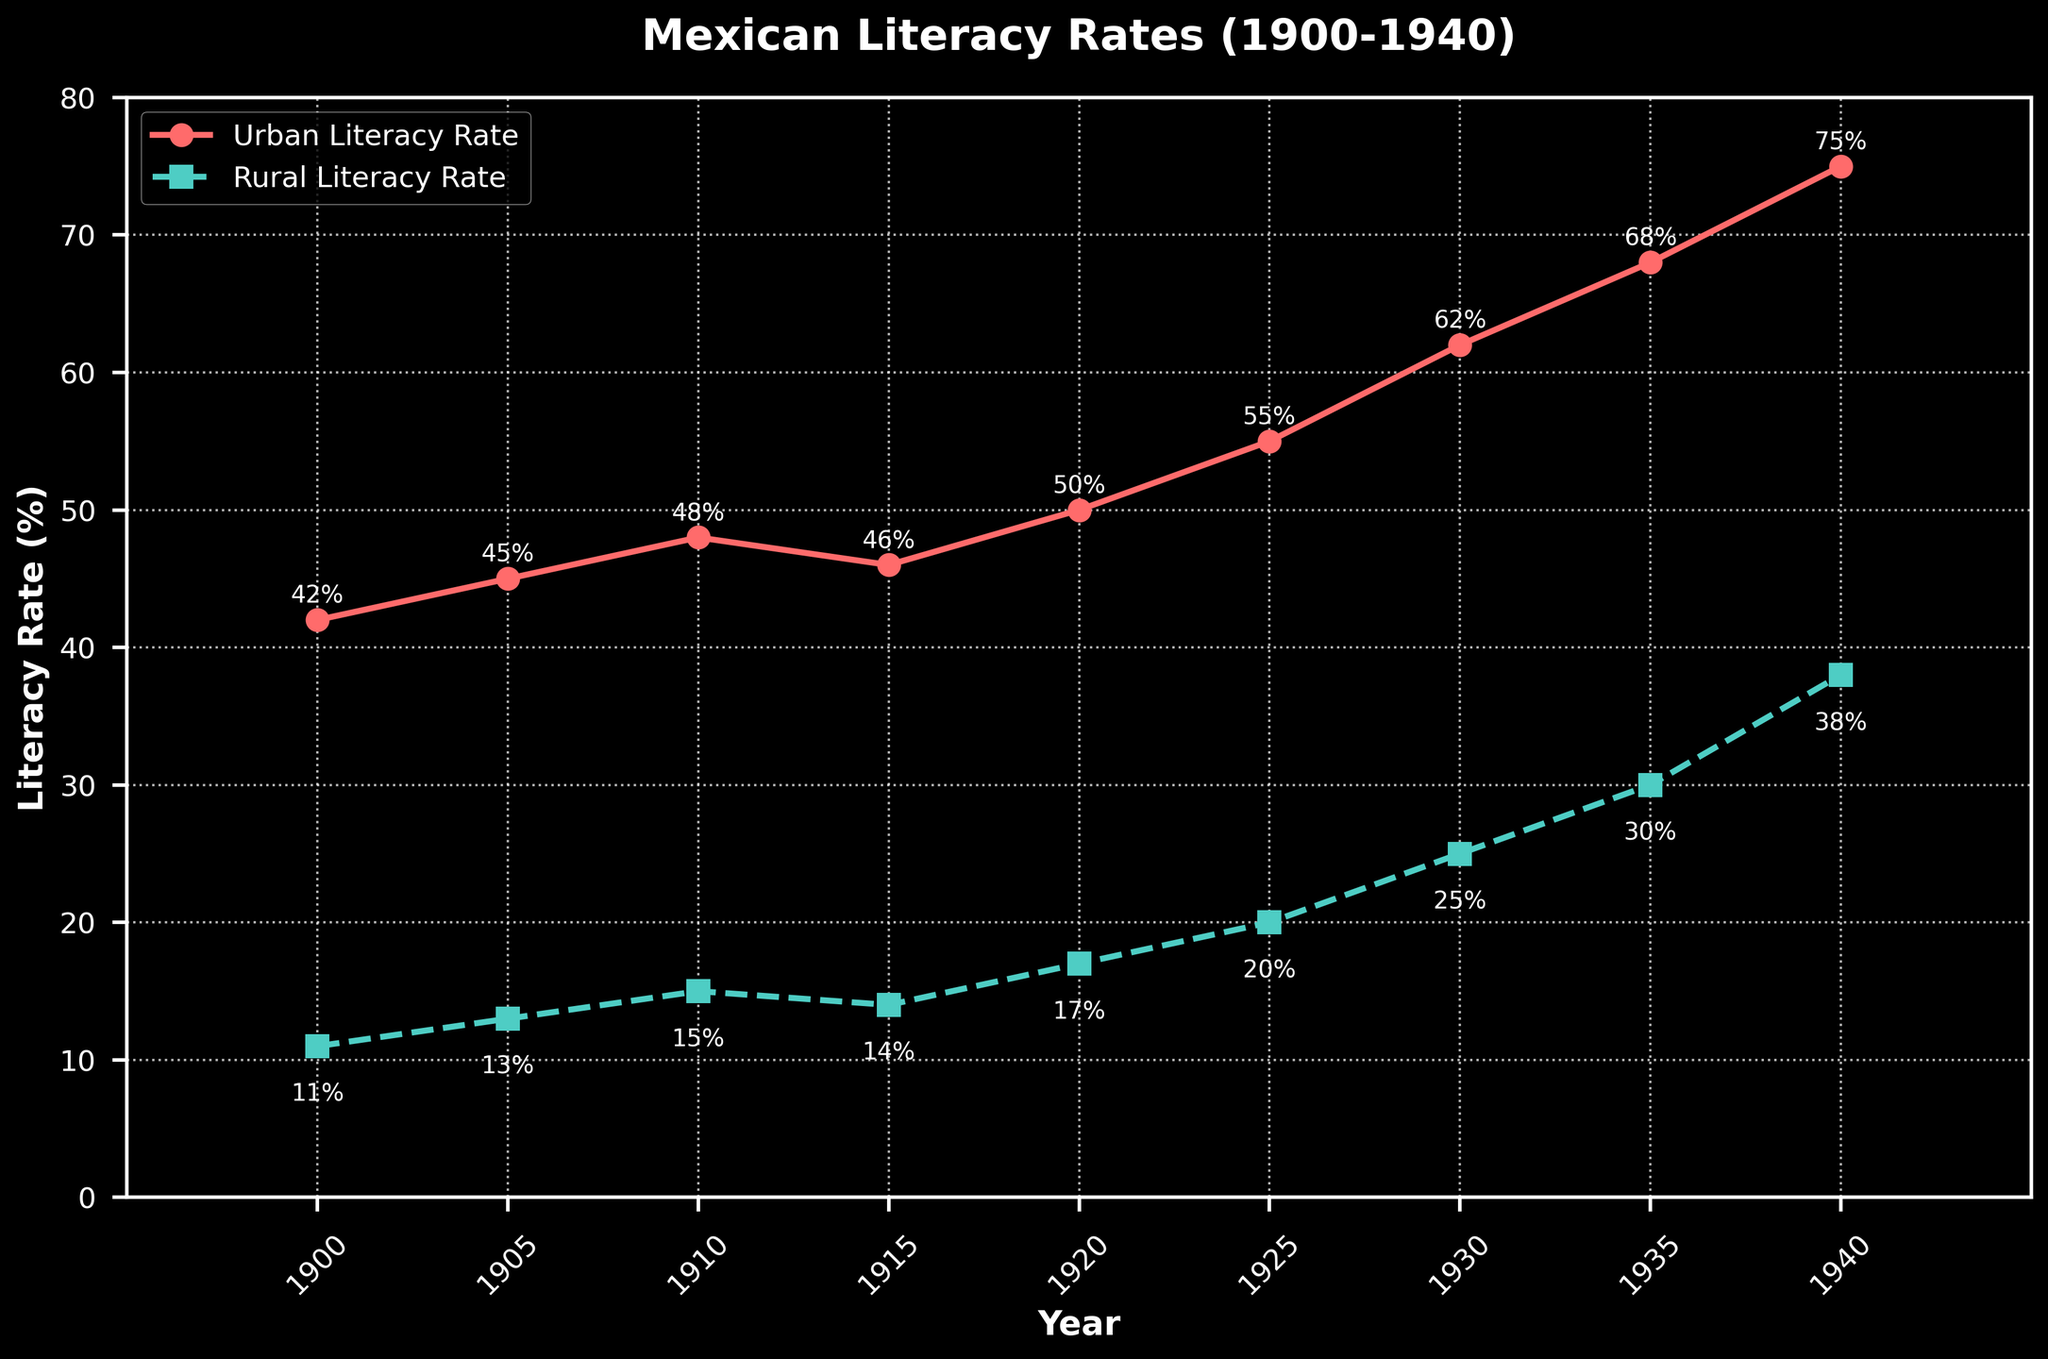What is the difference between urban and rural literacy rates in 1910? The urban literacy rate in 1910 is 48%, and the rural literacy rate is 15%. Subtracting the rural rate from the urban rate gives 48% - 15% = 33%.
Answer: 33% What is the average urban literacy rate over the decades shown? Adding the urban literacy rates and then dividing by the number of data points: (42 + 45 + 48 + 46 + 50 + 55 + 62 + 68 + 75) / 9 ≈ 54.67%.
Answer: 54.67% In which year did the rural literacy rate experience the largest increase compared to the previous data point? Comparing consecutive years: (1900 to 1905: 13 - 11 = 2), (1905 to 1910: 15 - 13 = 2), (1910 to 1915: 14 - 15 = -1), (1915 to 1920: 17 - 14 = 3), (1920 to 1925: 20 - 17 = 3), (1925 to 1930: 25 - 20 = 5), (1930 to 1935: 30 - 25 = 5), (1935 to 1940: 38 - 30 = 8). The largest increase (8%) occurred from 1935 to 1940.
Answer: 1935 to 1940 What is the combined literacy rate for urban and rural areas in 1920? In 1920, the urban literacy rate is 50%, and the rural literacy rate is 17%. Summing these gives 50% + 17% = 67%.
Answer: 67% Between 1915 and 1920, did the urban or rural literacy rate increase more? The urban literacy rate increased from 46% to 50% (4%), and the rural literacy rate increased from 14% to 17% (3%). The urban literacy rate increased more.
Answer: Urban How many years did it take for the urban literacy rate to increase from 55% to 75%? The urban literacy rate was 55% in 1925 and 75% in 1940. The number of years between 1925 and 1940 is 15 years.
Answer: 15 years Which literacy rate was higher in 1935, urban or rural? In 1935, the urban literacy rate is 68%, and the rural literacy rate is 30%. The urban literacy rate is higher.
Answer: Urban What are the two years when the urban literacy rate decreased? The urban literacy rate decreased between 1910-1915 (48% to 46%). This is the only decrease shown.
Answer: 1910 and 1915 How does the rural literacy rate in 1940 compare with the urban literacy rate in 1900? The rural literacy rate in 1940 is 38%, and the urban literacy rate in 1900 is 42%. The rural literacy rate in 1940 is 4% less than the urban rate in 1900.
Answer: 4% less 